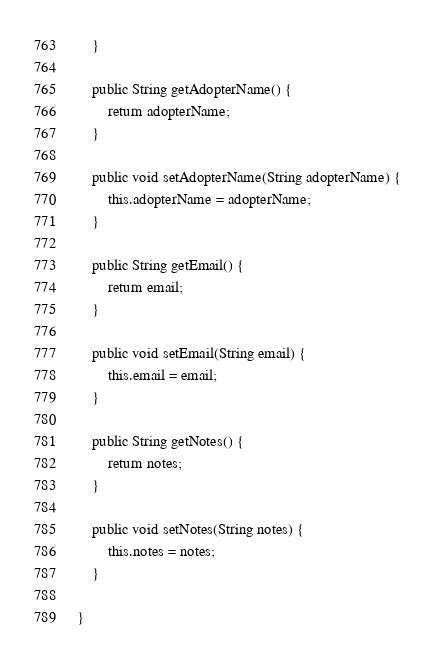<code> <loc_0><loc_0><loc_500><loc_500><_Java_>	}

	public String getAdopterName() {
		return adopterName;
	}

	public void setAdopterName(String adopterName) {
		this.adopterName = adopterName;
	}

	public String getEmail() {
		return email;
	}

	public void setEmail(String email) {
		this.email = email;
	}

	public String getNotes() {
		return notes;
	}

	public void setNotes(String notes) {
		this.notes = notes;
	}

}
</code> 